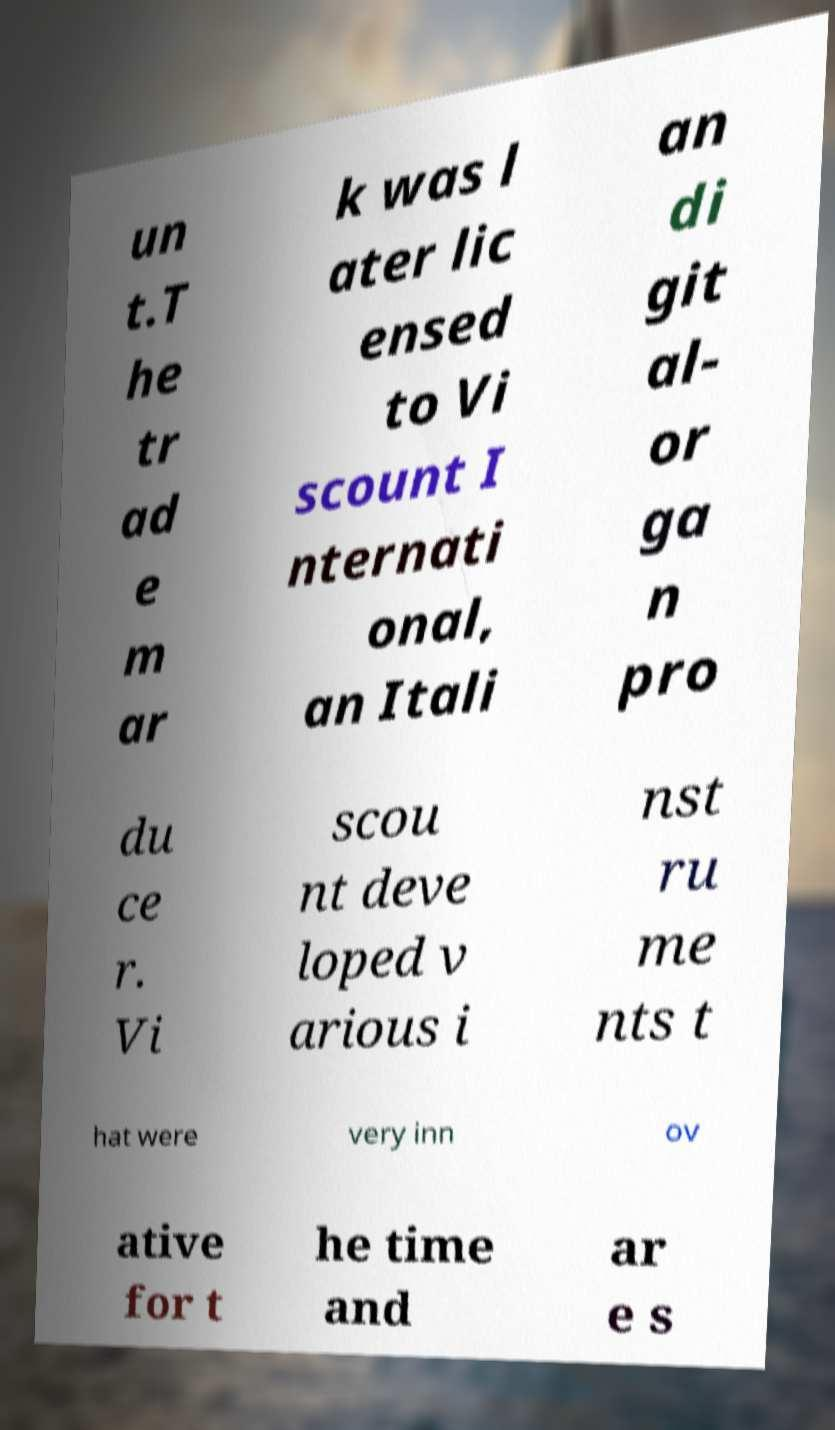Please read and relay the text visible in this image. What does it say? un t.T he tr ad e m ar k was l ater lic ensed to Vi scount I nternati onal, an Itali an di git al- or ga n pro du ce r. Vi scou nt deve loped v arious i nst ru me nts t hat were very inn ov ative for t he time and ar e s 